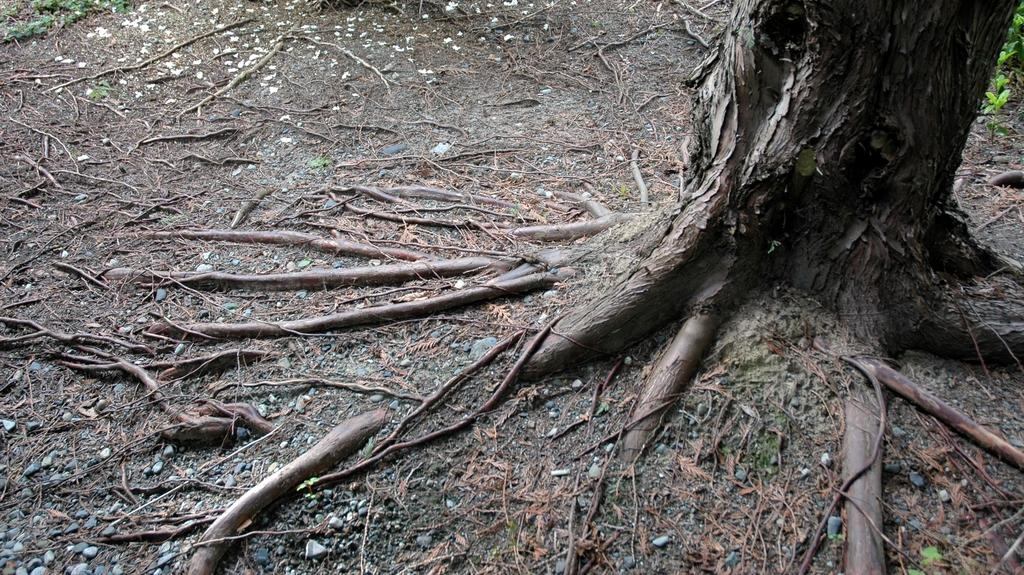What type of vegetation is on the right side of the image? There is a tree on the right side of the image. What is at the bottom of the image? There is sand at the bottom of the image. What can be seen at the base of the tree? There are roots visible at the bottom of the image. What type of vegetation is in the background of the image? There is grass in the background of the image. What type of band is playing music in the image? There is no band present in the image; it features a tree, sand, roots, and grass. 